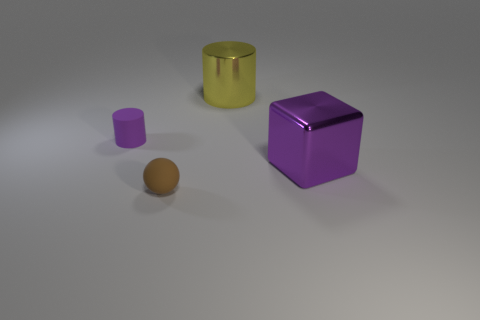Add 2 big things. How many objects exist? 6 Subtract all spheres. How many objects are left? 3 Add 2 brown rubber things. How many brown rubber things exist? 3 Subtract 0 brown blocks. How many objects are left? 4 Subtract all cubes. Subtract all small cyan things. How many objects are left? 3 Add 2 small matte cylinders. How many small matte cylinders are left? 3 